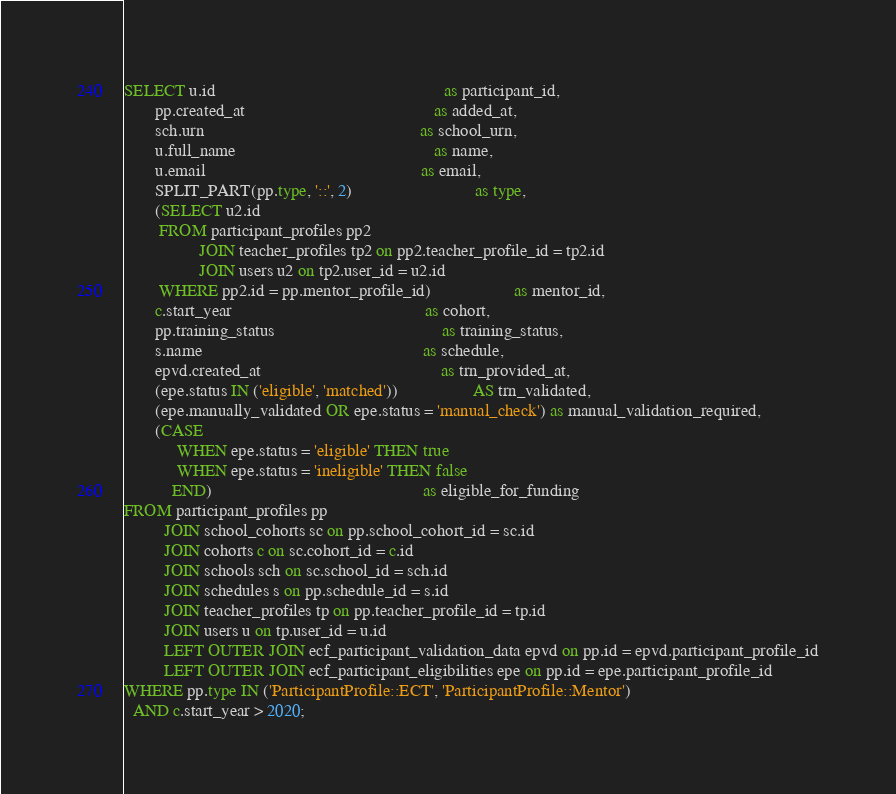Convert code to text. <code><loc_0><loc_0><loc_500><loc_500><_SQL_>SELECT u.id                                                    as participant_id,
       pp.created_at                                           as added_at,
       sch.urn                                                 as school_urn,
       u.full_name                                             as name,
       u.email                                                 as email,
       SPLIT_PART(pp.type, '::', 2)                            as type,
       (SELECT u2.id
        FROM participant_profiles pp2
                 JOIN teacher_profiles tp2 on pp2.teacher_profile_id = tp2.id
                 JOIN users u2 on tp2.user_id = u2.id
        WHERE pp2.id = pp.mentor_profile_id)                   as mentor_id,
       c.start_year                                            as cohort,
       pp.training_status                                      as training_status,
       s.name                                                  as schedule,
       epvd.created_at                                         as trn_provided_at,
       (epe.status IN ('eligible', 'matched'))                 AS trn_validated,
       (epe.manually_validated OR epe.status = 'manual_check') as manual_validation_required,
       (CASE
            WHEN epe.status = 'eligible' THEN true
            WHEN epe.status = 'ineligible' THEN false
           END)                                                as eligible_for_funding
FROM participant_profiles pp
         JOIN school_cohorts sc on pp.school_cohort_id = sc.id
         JOIN cohorts c on sc.cohort_id = c.id
         JOIN schools sch on sc.school_id = sch.id
         JOIN schedules s on pp.schedule_id = s.id
         JOIN teacher_profiles tp on pp.teacher_profile_id = tp.id
         JOIN users u on tp.user_id = u.id
         LEFT OUTER JOIN ecf_participant_validation_data epvd on pp.id = epvd.participant_profile_id
         LEFT OUTER JOIN ecf_participant_eligibilities epe on pp.id = epe.participant_profile_id
WHERE pp.type IN ('ParticipantProfile::ECT', 'ParticipantProfile::Mentor')
  AND c.start_year > 2020;</code> 